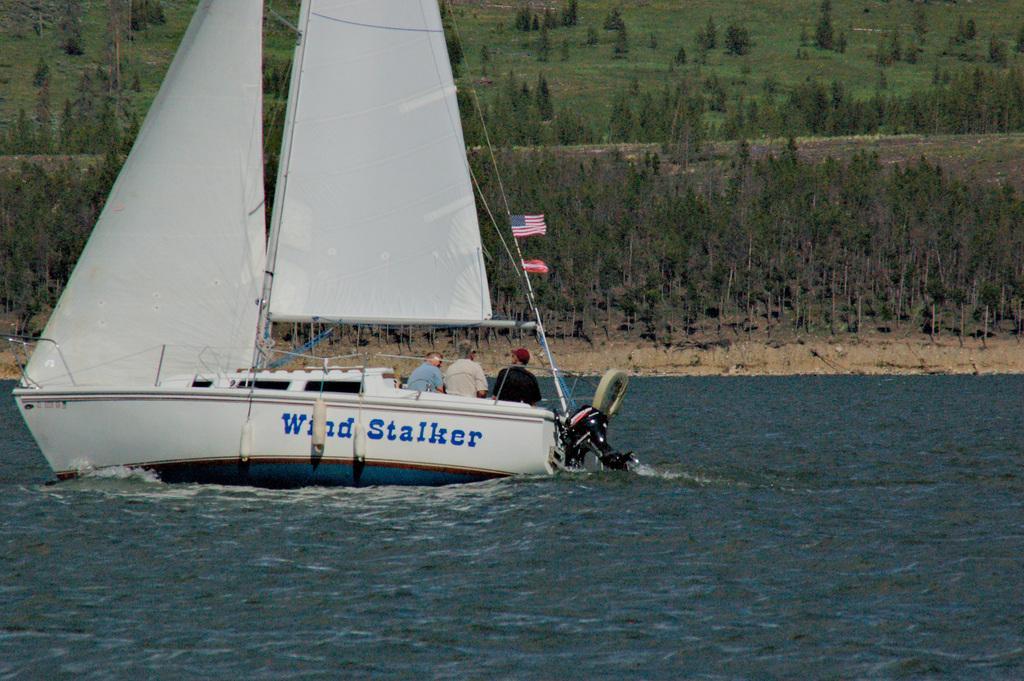In one or two sentences, can you explain what this image depicts? In this image at the bottom there is a river, in that river there is one ship and in the ship there are some persons and some flags and some other objects. And in the background there are some trees and grass. 